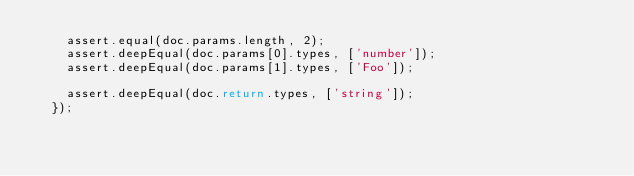Convert code to text. <code><loc_0><loc_0><loc_500><loc_500><_JavaScript_>    assert.equal(doc.params.length, 2);
    assert.deepEqual(doc.params[0].types, ['number']);
    assert.deepEqual(doc.params[1].types, ['Foo']);

    assert.deepEqual(doc.return.types, ['string']);
  });
</code> 